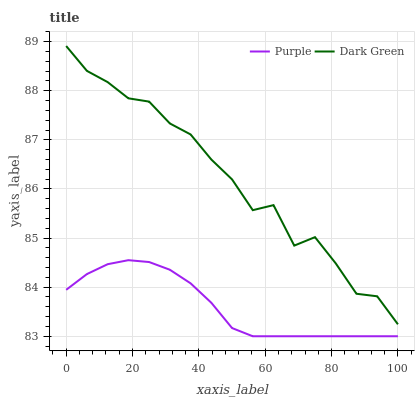Does Dark Green have the minimum area under the curve?
Answer yes or no. No. Is Dark Green the smoothest?
Answer yes or no. No. Does Dark Green have the lowest value?
Answer yes or no. No. Is Purple less than Dark Green?
Answer yes or no. Yes. Is Dark Green greater than Purple?
Answer yes or no. Yes. Does Purple intersect Dark Green?
Answer yes or no. No. 